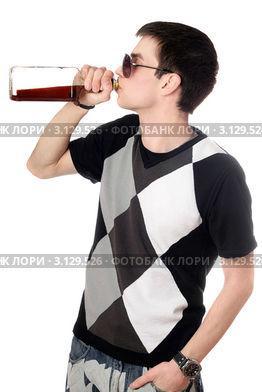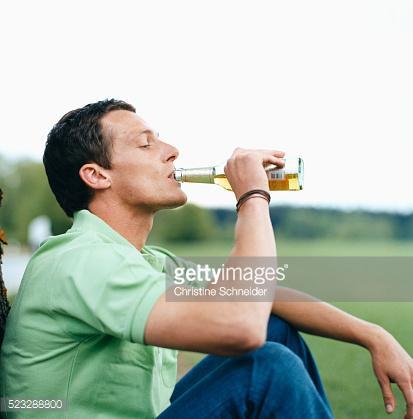The first image is the image on the left, the second image is the image on the right. Assess this claim about the two images: "The left and right image contains the same number of men standing drinking a single beer.". Correct or not? Answer yes or no. No. The first image is the image on the left, the second image is the image on the right. Considering the images on both sides, is "One of these guys does not have a beer bottle at their lips." valid? Answer yes or no. No. 